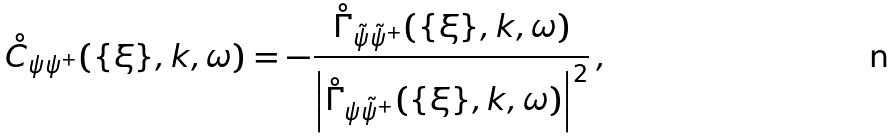Convert formula to latex. <formula><loc_0><loc_0><loc_500><loc_500>\mathring { C } _ { \psi \psi ^ { + } } ( \{ \xi \} , k , \omega ) = - \frac { \mathring { \Gamma } _ { \tilde { \psi } \tilde { \psi } ^ { + } } ( \{ \xi \} , k , \omega ) } { \left | \mathring { \Gamma } _ { \psi \tilde { \psi } ^ { + } } ( \{ \xi \} , k , \omega ) \right | ^ { 2 } } \, ,</formula> 